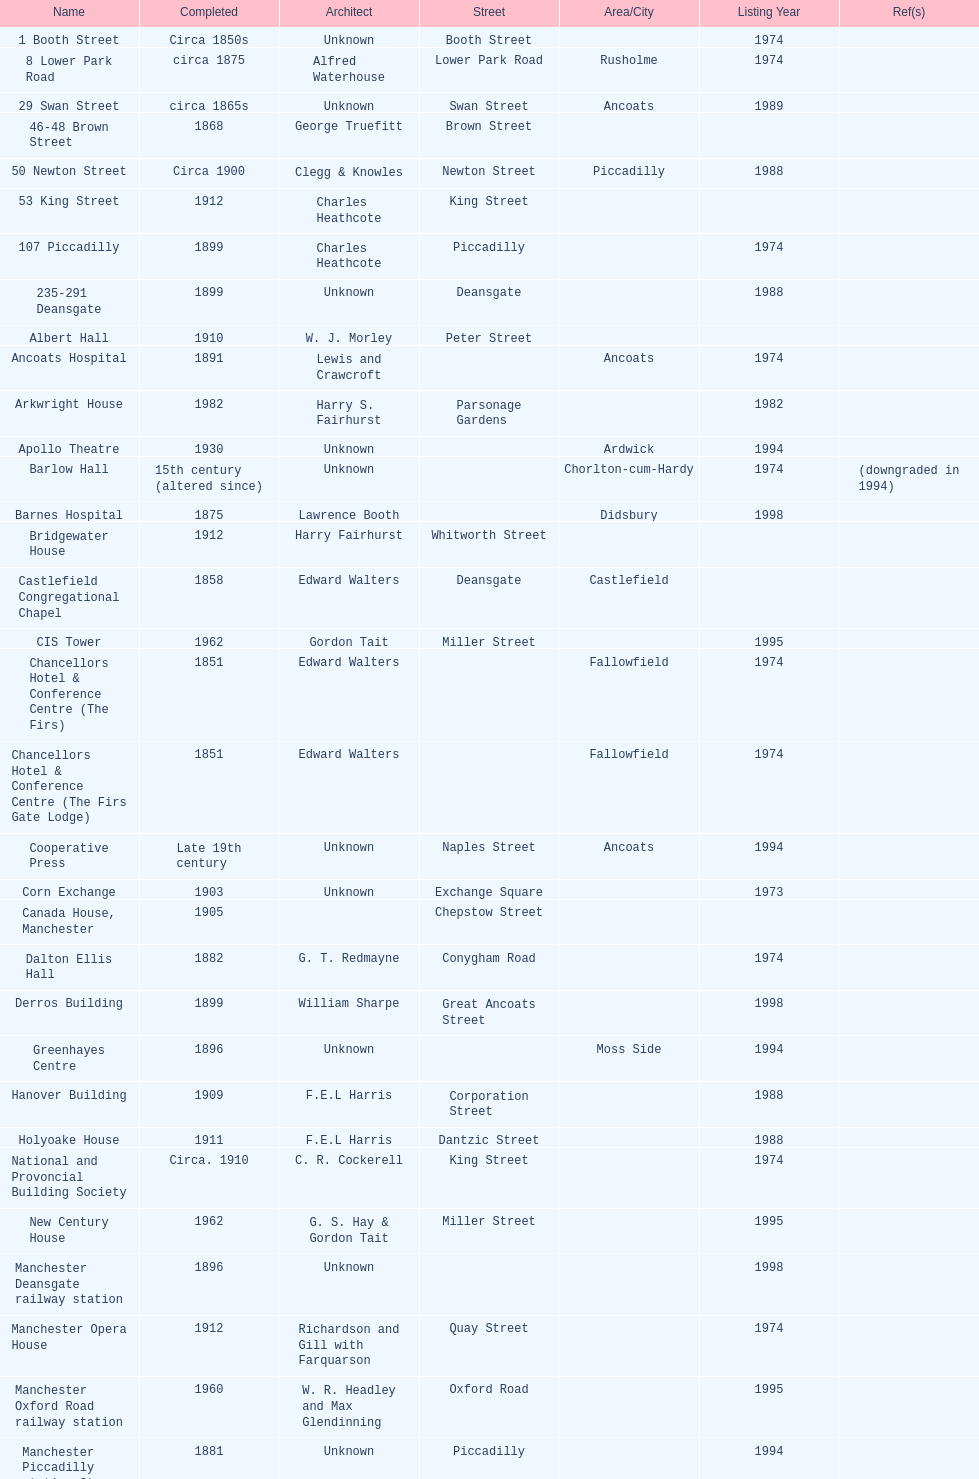Was charles heathcote the architect of ancoats hospital and apollo theatre? No. 